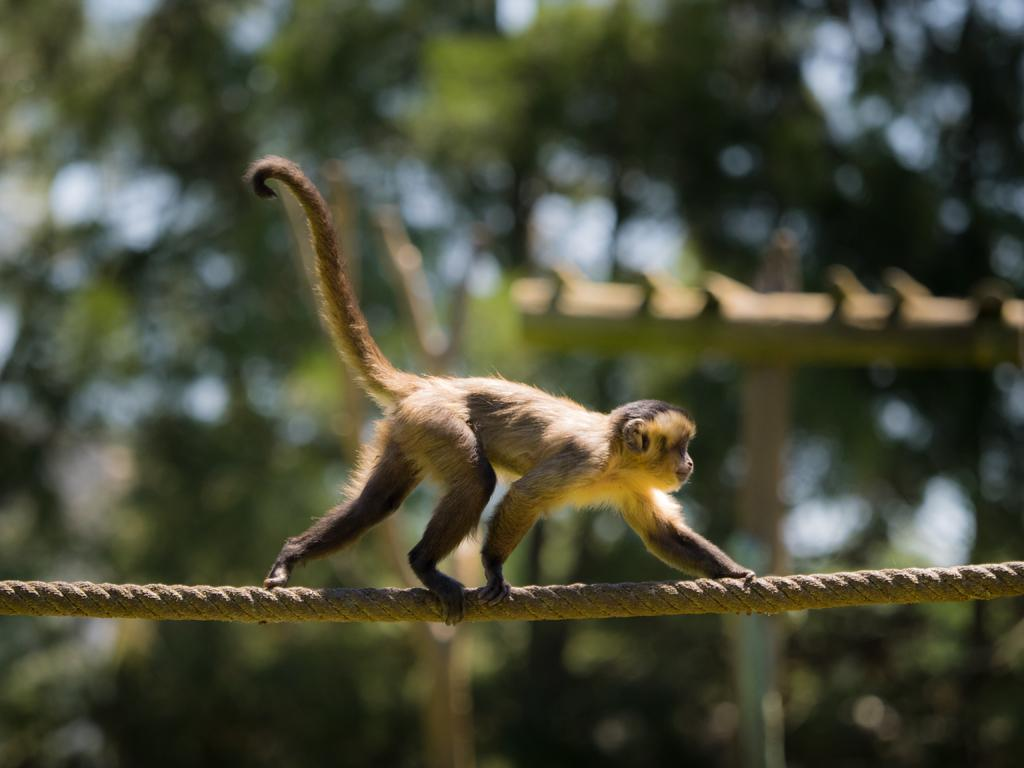What animal is present in the image? There is a monkey in the image. What is the monkey doing in the image? The monkey is walking on a rope. In which direction is the monkey moving? The monkey is moving towards the right side of the image. What can be seen in the background of the image? There are trees and sticks visible in the background of the image. What type of instrument is the monkey playing in the image? There is no instrument present in the image, and the monkey is not playing any instrument. 